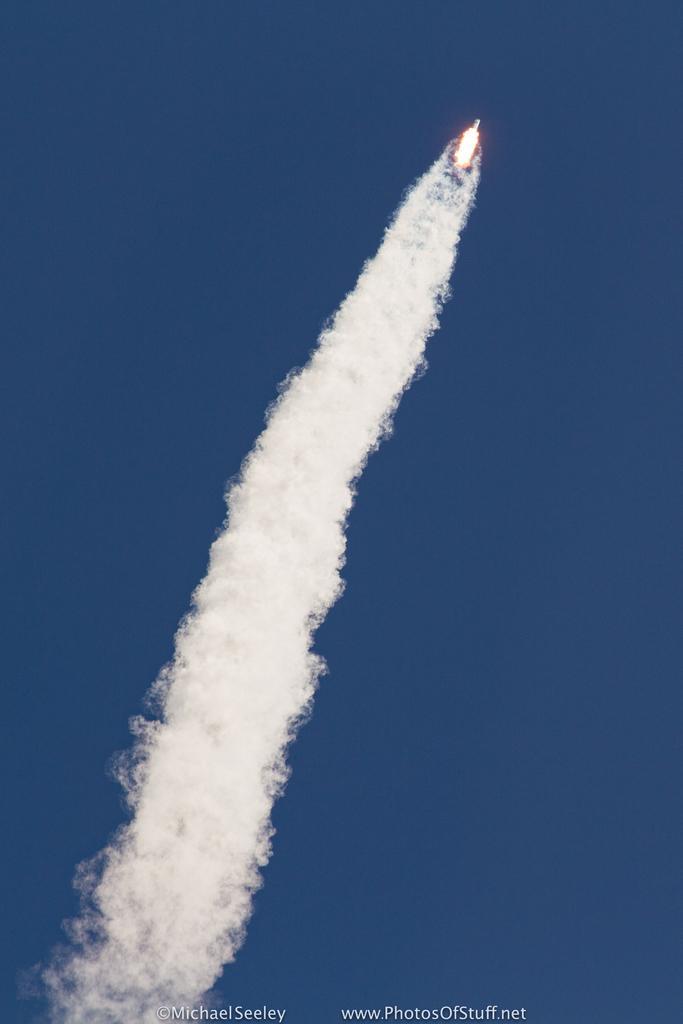Describe this image in one or two sentences. In this image there is a rocket flying in the sky with smoke behind the rocket. 